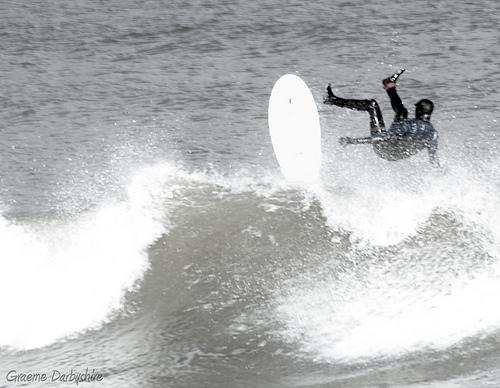Analyze the image for sentiment and provide an appropriate response. The image evokes a sense of excitement and athleticism as the surfer attempts to ride the dynamic ocean wave but ends up falling into the water. Based on the image provided, count the number of waves visible in the image. There are two waves described: a large ocean wave and a wave of water. Provide a reasoning and explanation for the surfer's current situation. The surfer is wiping out likely due to the complexity of the wave breaking in different places and the presence of small swells and ripples in the ocean water, making it difficult to maintain balance on the surfboard. In your own words, explain what's happening with the surfer in the image. The surfer, wearing a full wet suit and water shoes, has lost his balance and is falling off his white surfboard into the slightly turbid ocean with small swells and ripples. Mention three details about the ocean water in this image. The ocean has grey waves with foamy caps breaking in different places, producing spray of water droplets and white water. Create an interesting caption for this image that describes the scene succinctly. "Wipeout! Surfer in black wet suit takes a splash as he loses balance on an ocean wave." How many surfboards are described in the image? There is one white surfboard in the image. For a VQA system, ask a question about the surfer's outfit and provide an answer based on the information given. The surfer's wet suit is black, and he is wearing black gloves. Provide a description of the surfer's clothing. The surfer is wearing a full black wet suit, black gloves, and water shoes. How do you describe the water in the image? Slightly turbid with small swells, ripples, and white water. Describe the scene in the image. A man in a wet suit is falling off a white surfboard into the slightly turbid water with large and small waves, and there's an ocean spray. Is the surfboard in a perpendicular position in the wave? Yes What is the color of the surfer's shoes? Black Explain the condition of the ocean in the image. The ocean has small swells, ripples, foamy caps of waves, and breaking waves in different places. Does the person wearing the wet suit have an orange color? The available information doesn't specify the suit color, but it's clear that it is described as a black wet suit elsewhere in the image. Is the surfer wearing any gloves? Yes, the surfer is wearing black gloves. What part of the surfer is visible behind the ocean spray? The back of his head Who is responsible for the photograph? Name of the photographer Is the surfer standing on the surfboard while riding the wave? The surfer is described as falling off the surfboard, flying through the air, and wiping out, indicating that they are not standing on the surfboard. Is there a sunset visible in the background of the image? There is no mention of a sunset or the background of the image. What is happening to the surfer in the water? The surfer is wiping out and falling into the water. Is the surfer wearing a wet suit? Yes, the surfer is wearing a full black wet suit. Can you see a dolphin swimming next to the surfer? There is no mention of a dolphin in the given information about the image. Is the surfer flying through the air? No, the surfer is falling off the surfboard into the water. Create a short story based on the image. On a sunny day, Jack decided to ride the perfect waves wearing his black wet suit, gloves, and water shoes. As he confidently treaded the grey, slightly turbid water, he caught a massive wave. Unfortunately, he lost his balance and wiped out, soaring through the air before crashing into the ocean. He emerged with a grin, ready to try again. Is the photographer's name written in large purple letters across the image? The only mention of the photographer's name refers to its position and size, but there is no mention of color or that it is written across the image. What are the different states of the waves in the image? Breaking, small swells, ripples, and over spray of the wave. Does the surfer have a long beard? There is no mention of the surfer's facial features, including a beard. What is the color of the surfboard? White Describe the man's position in relation to the wave. The man is falling off the surfboard into the breaking wave. What activity is the person engaged in? Surfing 